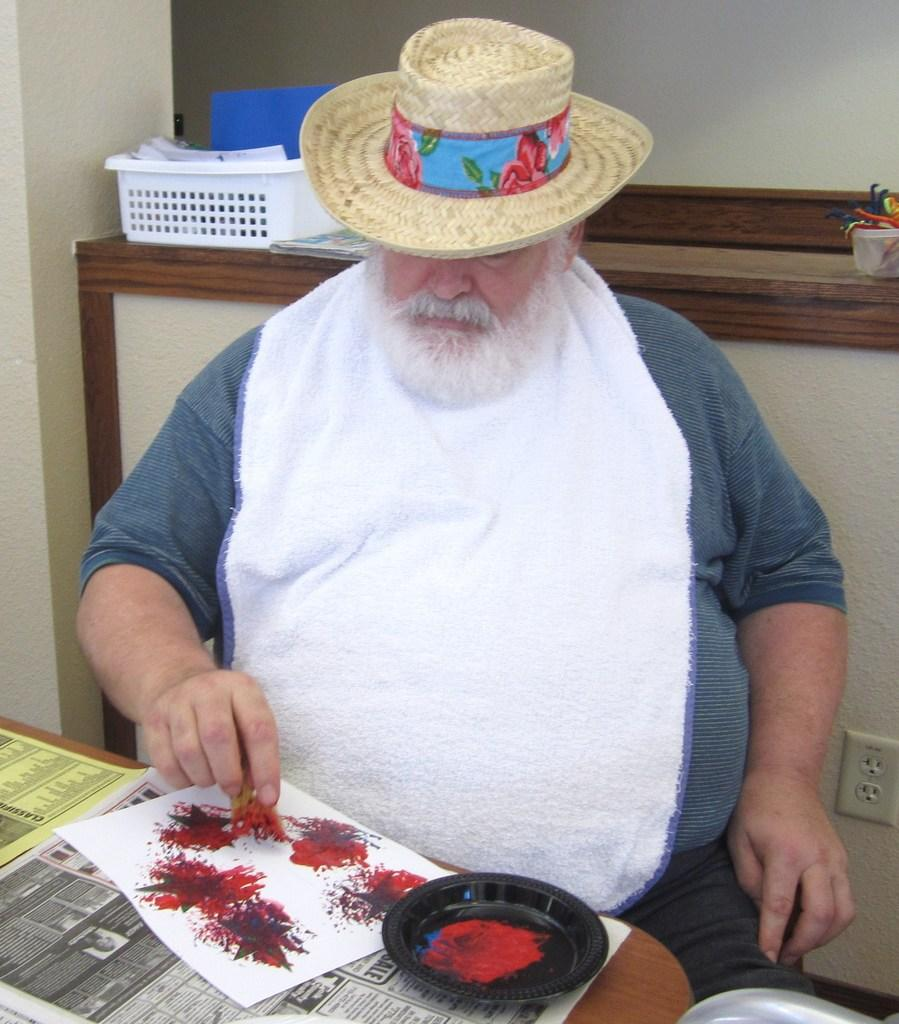Who is present in the image? There is a man in the image. What is the man wearing on his head? The man is wearing a hat. What object can be seen in the image that is typically used for carrying items? There is a tray in the image. What type of material is visible in the image that can be written or drawn on? There is paper in the image. What is another object present in the image that can hold food? There is a plate in the image. How does the man rub the desk in the image? There is no desk present in the image, so the man cannot rub it. 